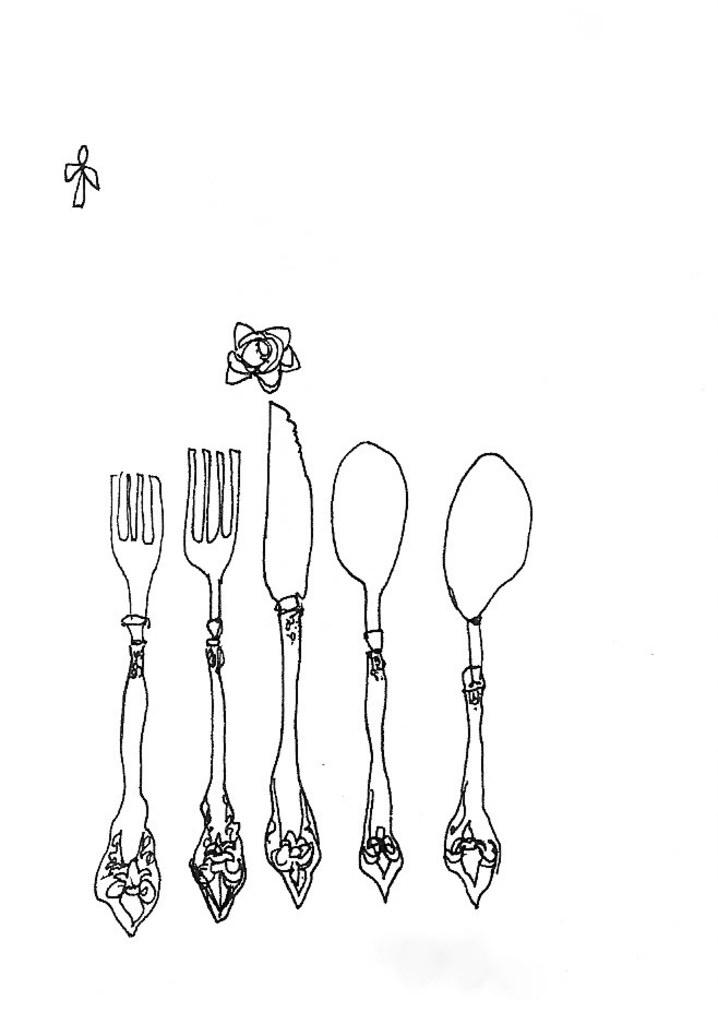What is the main subject of the image? There is a drawing in the image. What type of beam is being used to create the smoke in the drawing? There is no beam or smoke present in the drawing; it is a simple drawing without any additional elements. 